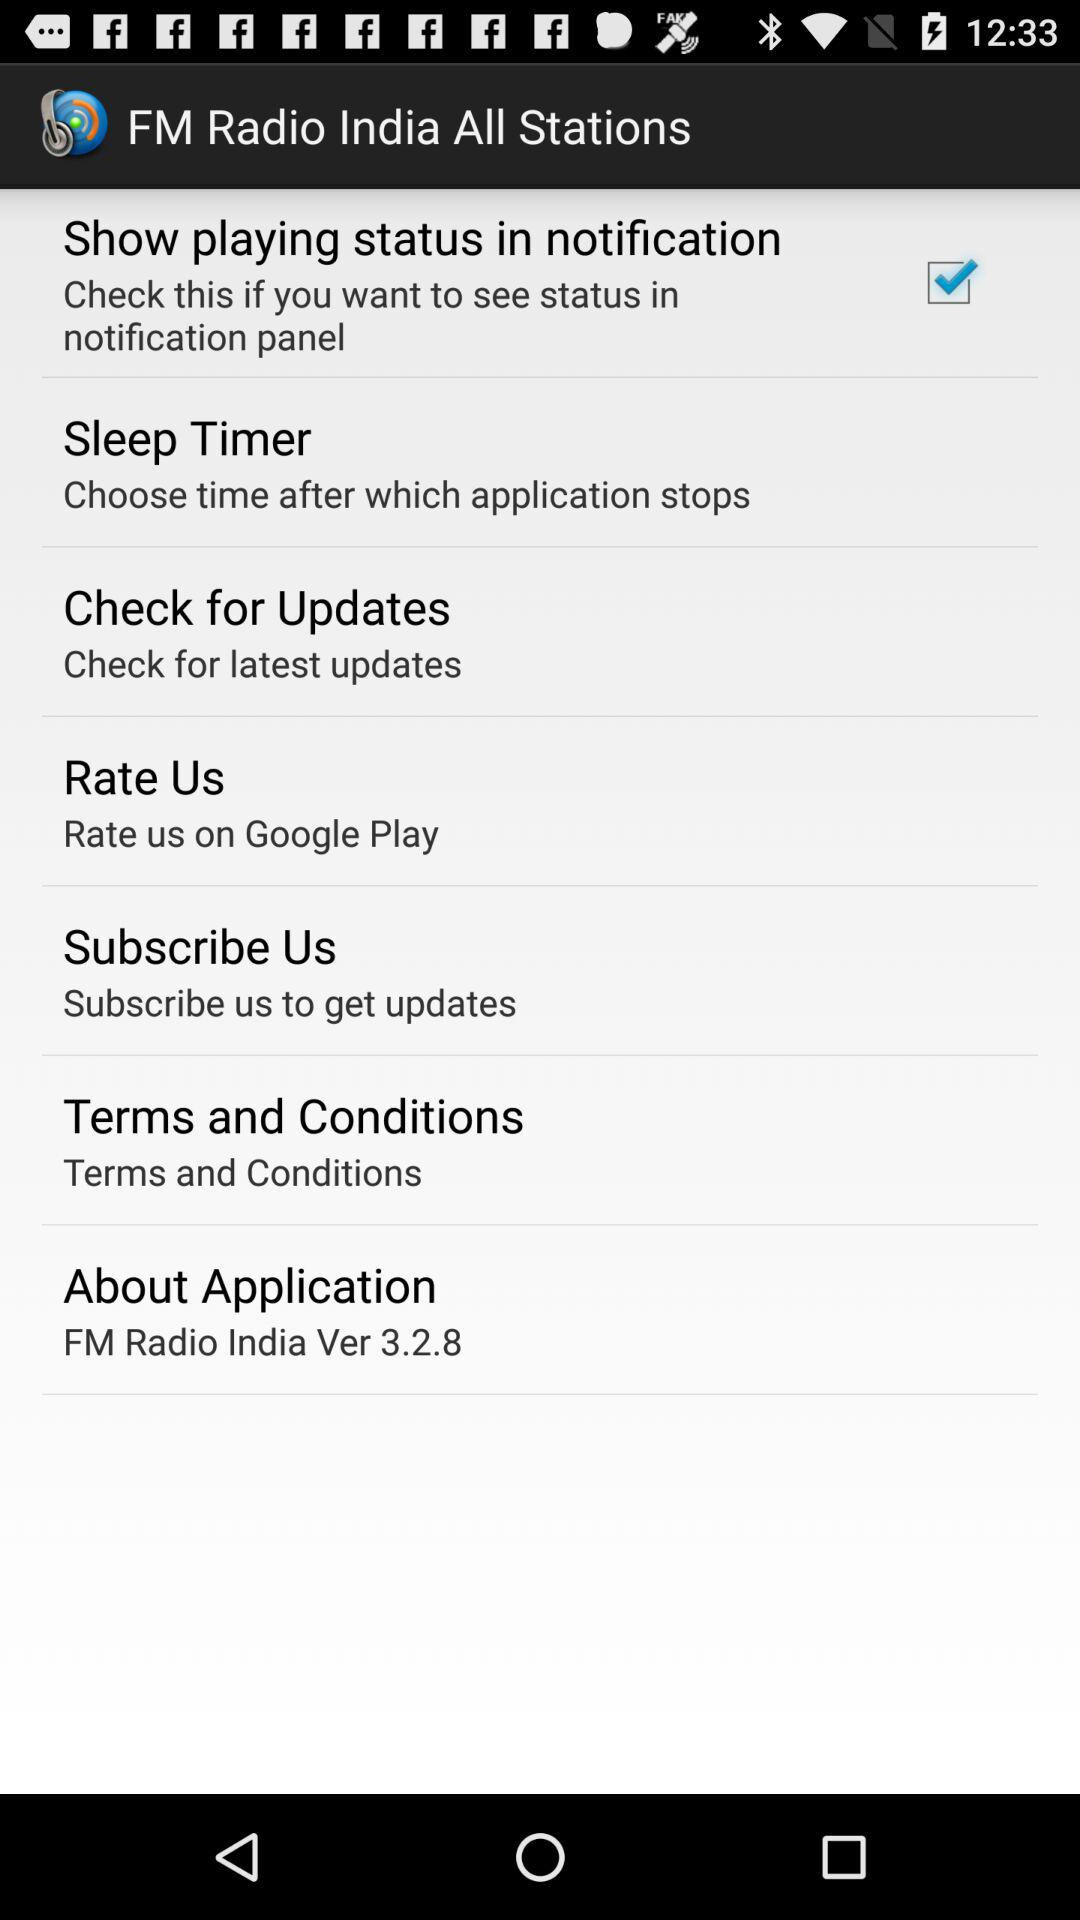What is the status of the "Show playing status in notification" settings? The status is on. 